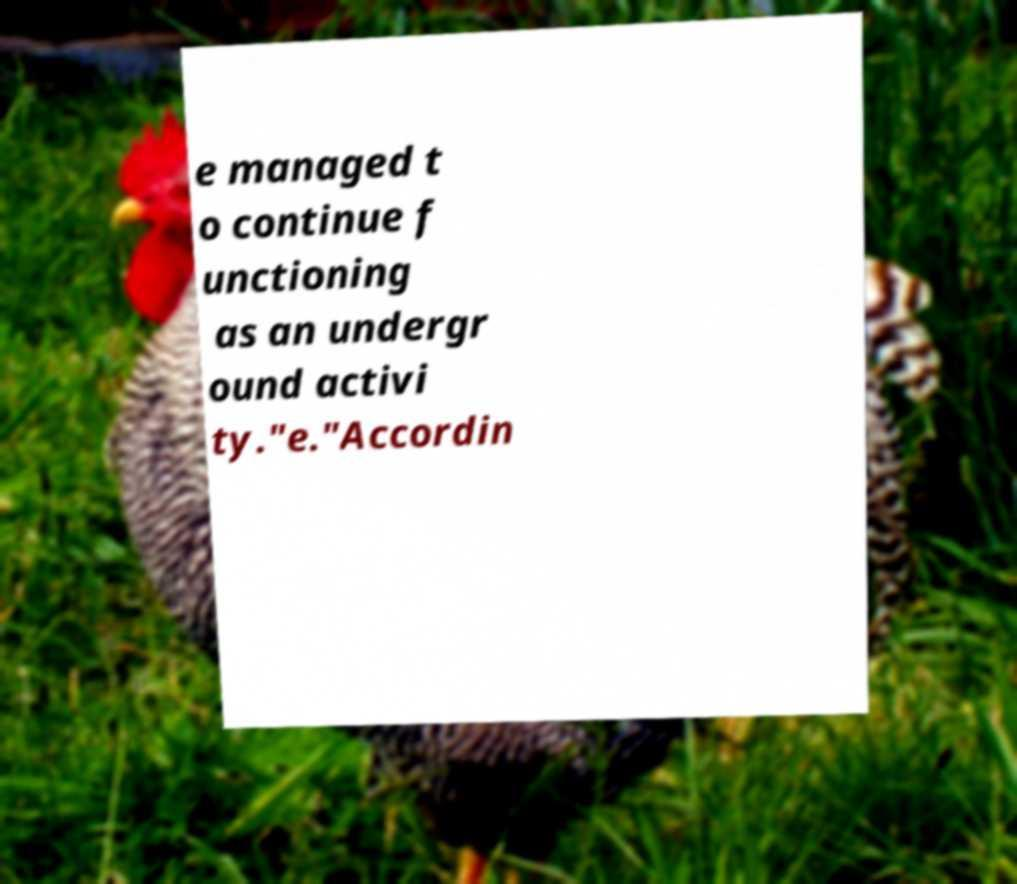For documentation purposes, I need the text within this image transcribed. Could you provide that? e managed t o continue f unctioning as an undergr ound activi ty."e."Accordin 